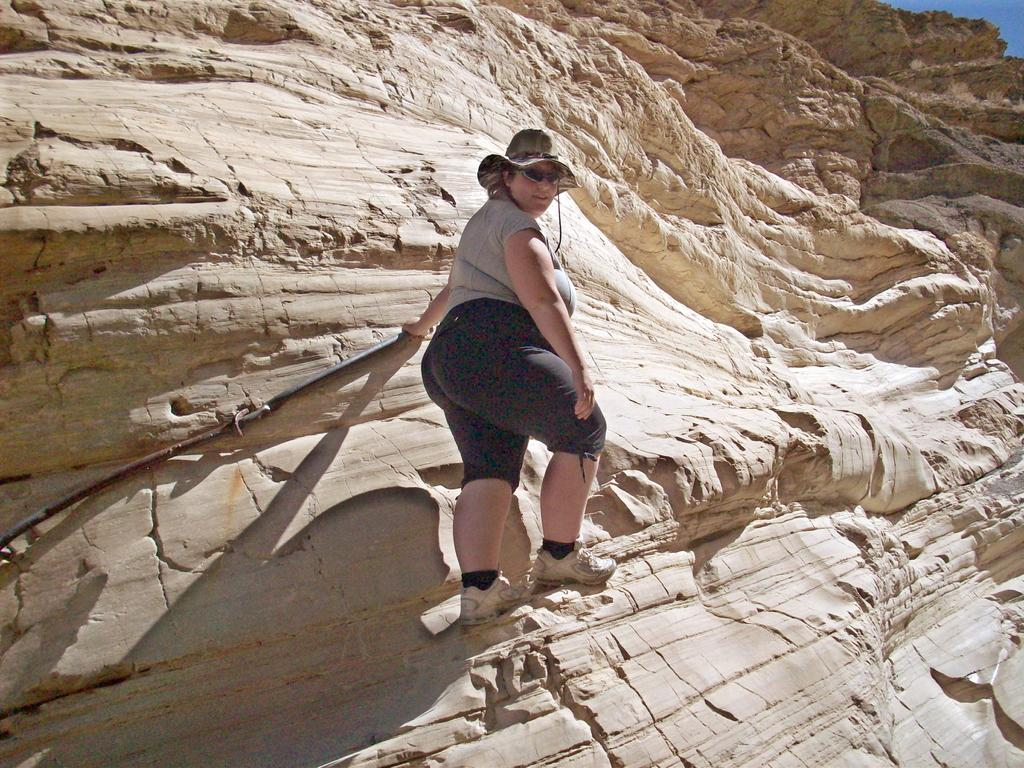Who is the main subject in the image? There is a woman in the image. What is the woman doing in the image? The woman is climbing a hill. What type of clothing is the woman wearing on her lower body? The woman is wearing trousers. What type of clothing is the woman wearing on her upper body? The woman is wearing a t-shirt. What type of footwear is the woman wearing? The woman is wearing shoes. What type of headwear is the woman wearing? The woman is wearing a hat. What type of plant is growing in the downtown area in the image? There is no mention of a downtown area or a plant in the image; it features a woman climbing a hill. 